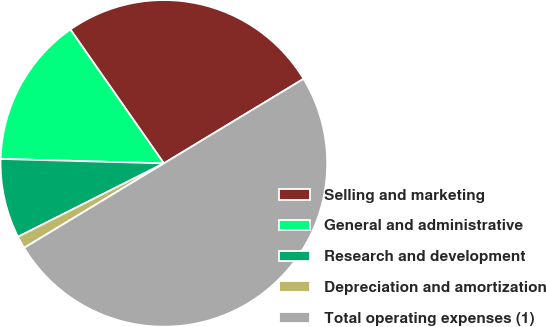<chart> <loc_0><loc_0><loc_500><loc_500><pie_chart><fcel>Selling and marketing<fcel>General and administrative<fcel>Research and development<fcel>Depreciation and amortization<fcel>Total operating expenses (1)<nl><fcel>26.04%<fcel>14.86%<fcel>7.86%<fcel>1.23%<fcel>50.0%<nl></chart> 